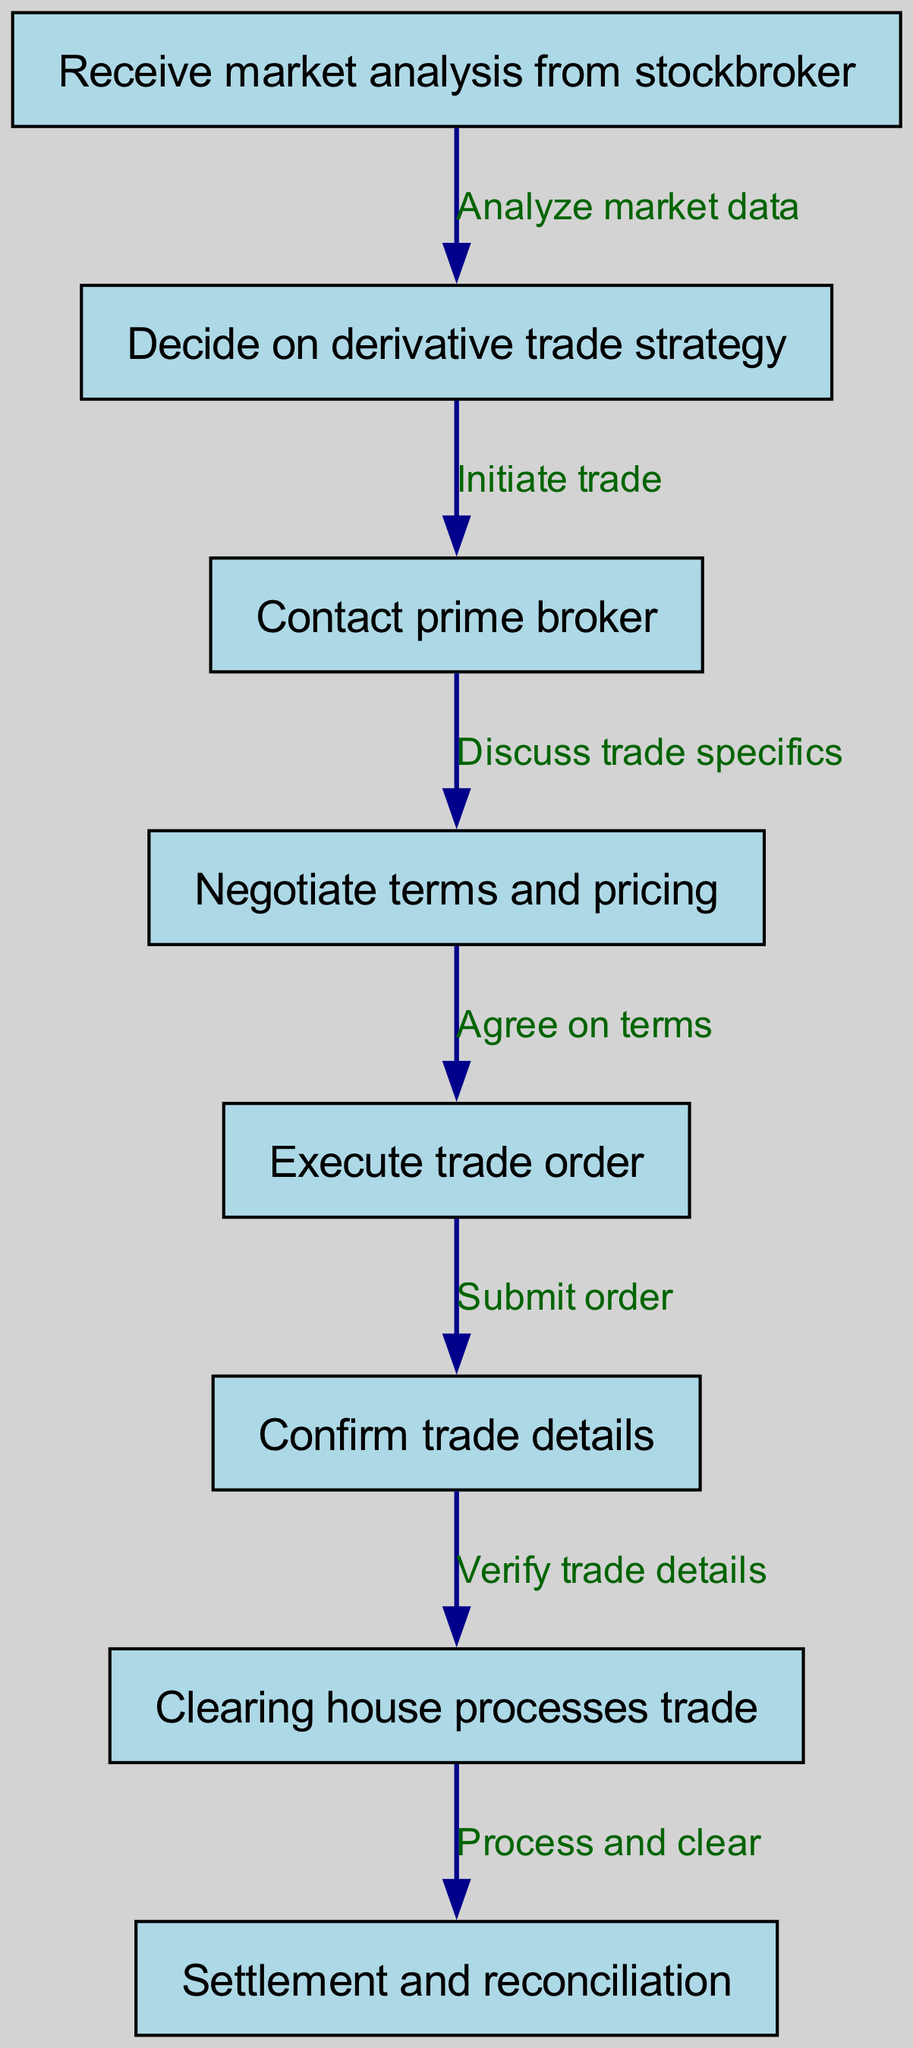What is the first step in the derivatives trade process? The first step in the process is to receive market analysis from the stockbroker, as indicated by the starting node in the flowchart.
Answer: Receive market analysis from stockbroker How many nodes are in the diagram? By counting each distinct step or decision represented in the diagram, there are a total of eight nodes present.
Answer: Eight What is the last step before the settlement? The last step before settlement is the clearing house processes the trade, as shown just before the final step in the flowchart.
Answer: Clearing house processes trade What is the relationship between nodes two and three? The relationship is that node two (Decide on derivative trade strategy) initiates the contact with the prime broker, as indicated by the directional edge connecting these nodes.
Answer: Initiate trade How many edges are there in the diagram? The total number of edges indicates the connections between the steps in the process, and there are seven edges shown in the flowchart.
Answer: Seven What details are confirmed after executing the trade order? After executing the trade order, the details of the trade are confirmed, linking the execution with the confirmation process as depicted in the flowchart.
Answer: Confirm trade details Which node discusses trade specifics? The node that discusses trade specifics is the one connected after contacting the prime broker, specifically node four in the flowchart.
Answer: Negotiate terms and pricing What is required to process and clear the trade? The trade must be verified for details after confirmation before it can be processed and cleared by the clearing house as shown in the sequential steps.
Answer: Verify trade details What is the penultimate step in the trading process? The penultimate step is where the clearing house processes the trade, which comes just before the settlement and reconciliation stage.
Answer: Clearing house processes trade 